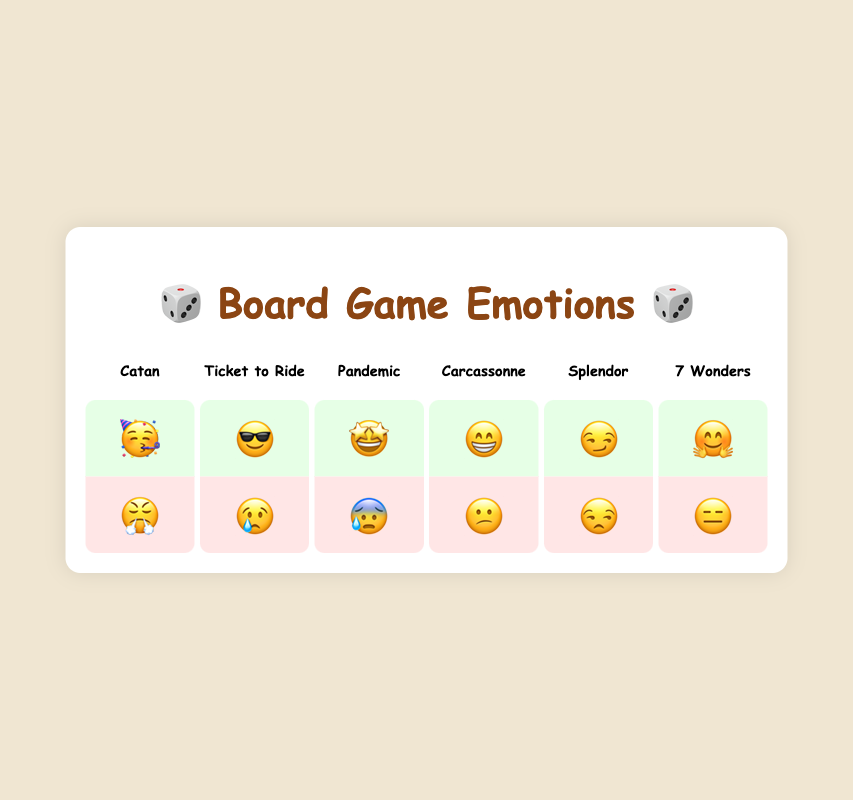Which board game has the emoji "🤗" for winning? According to the visual chart, look for the game label associated with the emoji "🤗" in the "win" section. The game name above the emoji is "7 Wonders".
Answer: 7 Wonders What's the difference in emotional reactions between winning and losing at "Pandemic"? Check the emotional expression associated with winning and losing for "Pandemic". Winning has "🤩" and losing has "😰".
Answer: Winning: 🤩, Losing: 😰 What's the facial expression for losing "Ticket to Ride"? Find the game "Ticket to Ride" and then look at the emoji in the "lose" section below it. It shows "😢".
Answer: 😢 Which game provokes a "😕" reaction upon losing? Locate the emoji "😕" in the "lose" section and look for the game title above it. The corresponding game is "Carcassonne".
Answer: Carcassonne Compare the winning emojis of "Splendor" and "Carcassonne". Which is more expressive? Look at the winning emojis for "Splendor" and "Carcassonne". "Splendor" has "😏" while "Carcassonne" has "😁". "Carcassonne" with "😁" is more expressive because it shows a big smile whereas "😏" is a more subdued smirk.
Answer: Carcassonne: 😁 Which board game has the most positive winning reaction between "Catan" and "Ticket to Ride"? Compare the winning emojis of "Catan" – "🥳" (party face) and "Ticket to Ride" – "😎" (cool face). "🥳" denotes a more enthusiastic celebration.
Answer: Catan: 🥳 If you win at "7 Wonders" and lose at "Splendor", how would you be feeling? Check the winning emoji for "7 Wonders" which is "🤗" and the losing emoji for "Splendor" which is "😒". Combining these, you would feel joyful and then a bit unimpressed.
Answer: Joyful (🤗) and Unimpressed (😒) What is the reaction for winning at "Pandemic" and losing at "Catan", and how might they contrast? Winning emoji for "Pandemic" is "🤩" (starry-eyed) and losing emoji for "Catan" is "😤" (angry). These reactions contrast significantly as "🤩" represents amazement while "😤" reveals frustration.
Answer: Starry-eyed (🤩) and Frustrated (😤) How do the losing reactions for "Splendor" and "7 Wonders" compare in terms of emotional intensity? Compare "Splendor" losing emoji "😒" (unamused) with "7 Wonders" losing emoji "😑" (expressionless). The "😒" emoji shows slightly more emotion than the "😑" emoji.
Answer: Splendor: Unamused (😒) more intense What are the emojis associated with both winning and losing "Carcassonne"? Look at both the "win" and "lose" sections for "Carcassonne". The win emoji is "😁" and the lose emoji is "😕".
Answer: Winning: 😁, Losing: 😕 